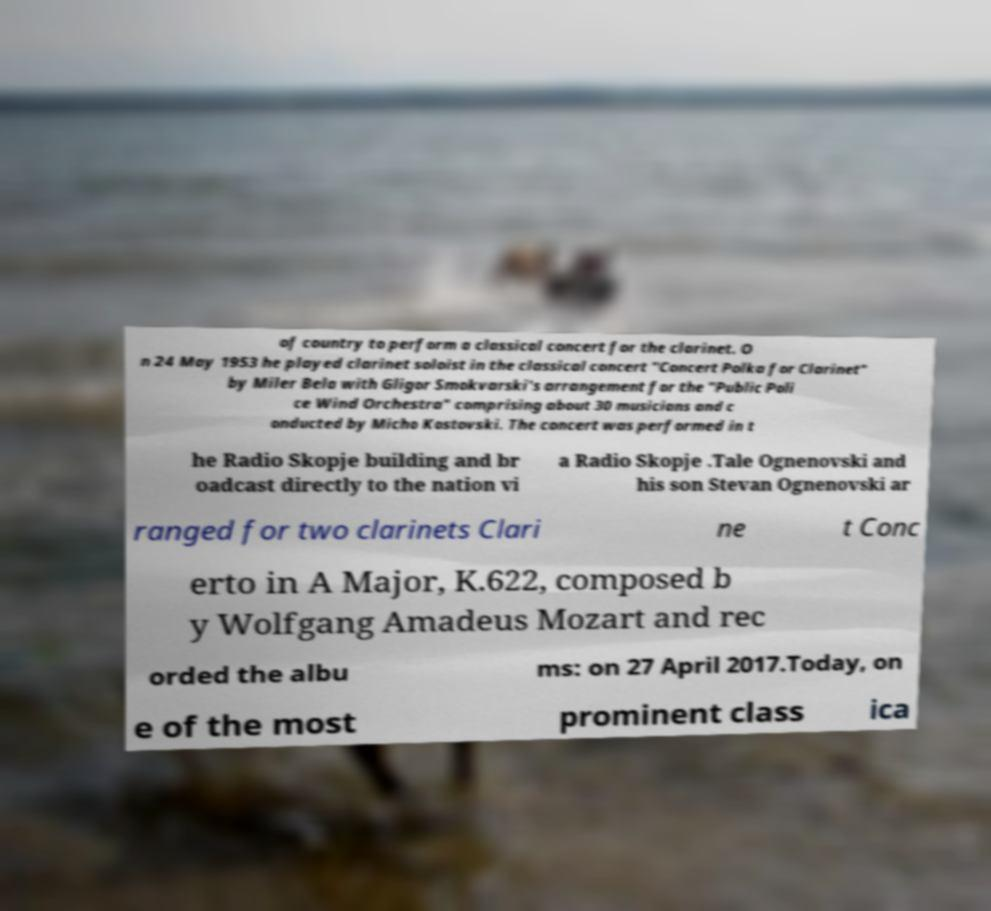What messages or text are displayed in this image? I need them in a readable, typed format. of country to perform a classical concert for the clarinet. O n 24 May 1953 he played clarinet soloist in the classical concert "Concert Polka for Clarinet" by Miler Bela with Gligor Smokvarski's arrangement for the "Public Poli ce Wind Orchestra" comprising about 30 musicians and c onducted by Micho Kostovski. The concert was performed in t he Radio Skopje building and br oadcast directly to the nation vi a Radio Skopje .Tale Ognenovski and his son Stevan Ognenovski ar ranged for two clarinets Clari ne t Conc erto in A Major, K.622, composed b y Wolfgang Amadeus Mozart and rec orded the albu ms: on 27 April 2017.Today, on e of the most prominent class ica 